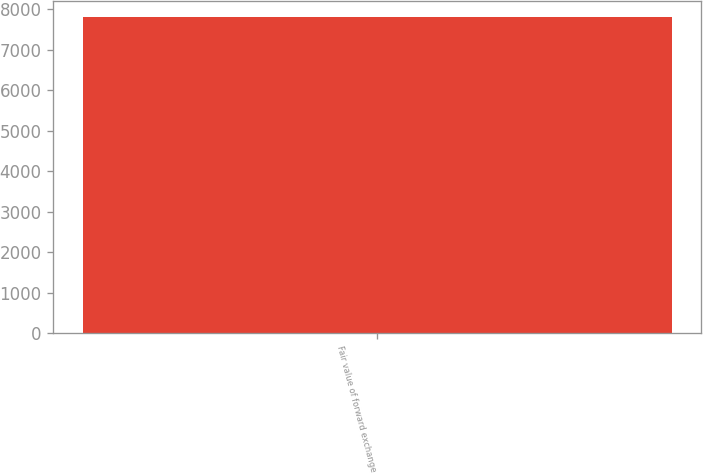Convert chart. <chart><loc_0><loc_0><loc_500><loc_500><bar_chart><fcel>Fair value of forward exchange<nl><fcel>7797.5<nl></chart> 